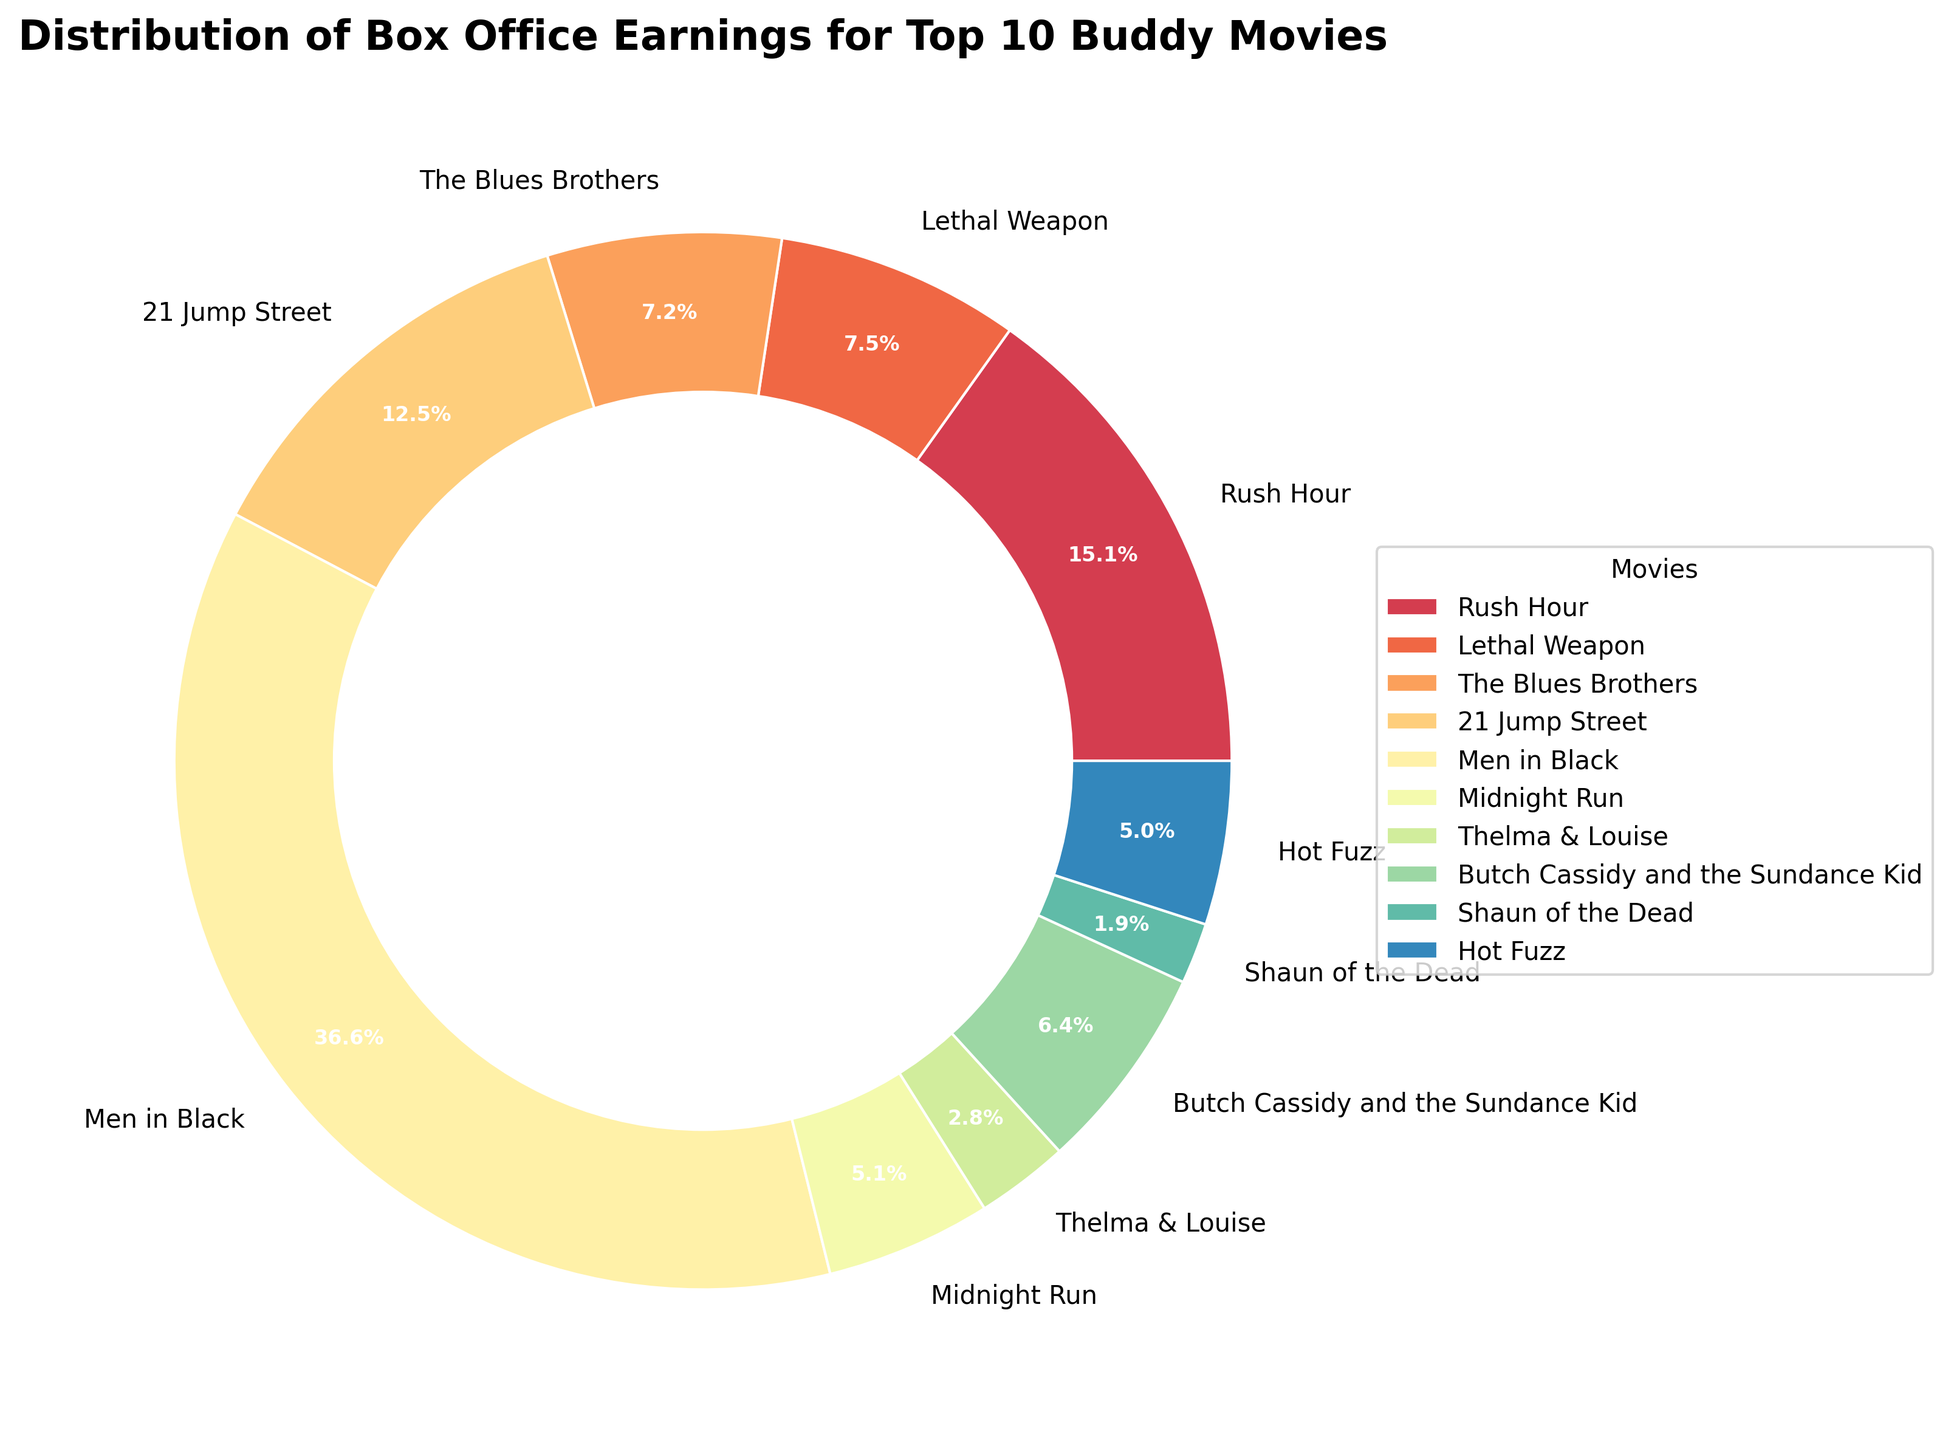What movie has the highest box office earnings? By looking at the size of the segments, we can see that the largest segment corresponds to "Men in Black". Therefore, "Men in Black" has the highest box office earnings.
Answer: Men in Black What percentage of the total box office earnings is contributed by "The Blues Brothers" and "Thelma & Louise" combined? From the pie chart, "The Blues Brothers" contributes 6.1% and "Thelma & Louise" contributes 2.4%. By adding these percentages, 6.1% + 2.4% = 8.5%.
Answer: 8.5% Which movie earned more, "Rush Hour" or "21 Jump Street"? By comparing the sizes of the segments, the segment for "Rush Hour" is larger than that for "21 Jump Street". Thus, "Rush Hour" earned more.
Answer: Rush Hour What is the difference in box office earnings between "Lethal Weapon" and "Shaun of the Dead"? From the chart, we see that "Lethal Weapon" has one segment and "Shaun of the Dead" has another. Subtracting their earnings: 120,200,000 - 30,039,392 = 90,160,608.
Answer: 90,160,608 How does the earnings of "Rush Hour" compare to "Hot Fuzz"? By observing their segments, "Rush Hour" has a much larger segment than "Hot Fuzz". Therefore, "Rush Hour" has higher earnings than "Hot Fuzz".
Answer: Rush Hour What is the average box office earnings of the top 3 highest-grossing movies? First, identify the top 3 highest-grossing movies: "Men in Black" (589,390,539), "Rush Hour" (244,000,000), and "21 Jump Street" (201,585,328). Adding their earnings and dividing by 3: (589,390,539 + 244,000,000 + 201,585,328) / 3 = 345,658,622.33.
Answer: 345,658,622.33 Which movie earned the least among the top 10 buddy movies? From the chart, the smallest segment corresponds to "Shaun of the Dead", indicating it earned the least.
Answer: Shaun of the Dead What is the combined percentage share of "Midnight Run" and "Thelma & Louise"? From the pie chart, "Midnight Run" contributes 4.3% and "Thelma & Louise" contributes 2.4%. Adding these percentages, 4.3% + 2.4% = 6.7%.
Answer: 6.7% Between "Butch Cassidy and the Sundance Kid" and "Lethal Weapon", which had more box office earnings, and by how much? The pie chart shows "Butch Cassidy and the Sundance Kid" with one segment and "Lethal Weapon" with another. Subtracting their earnings: 120,200,000 - 102,308,900 = 17,891,100. "Lethal Weapon" earned more.
Answer: Lethal Weapon, 17,891,100 What are the earnings of the movies contributing more than 10% of the total pie? From the chart, "Men in Black" (44.1%) and "Rush Hour" (18.2%) both exceed 10%. Their earnings are 589,390,539 and 244,000,000, respectively.
Answer: Men in Black, Rush Hour 